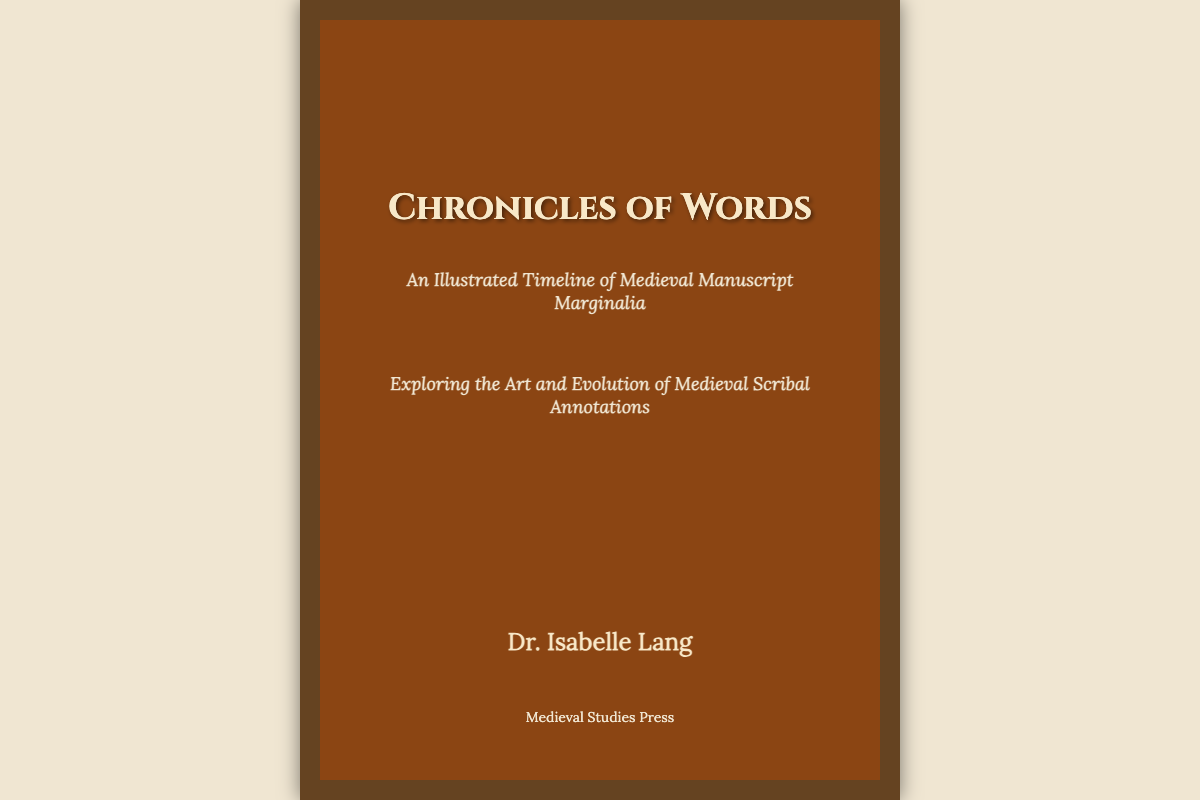What is the title of the book? The title of the book is prominently displayed at the top of the cover.
Answer: Chronicles of Words Who is the author? The author's name is listed near the bottom of the cover.
Answer: Dr. Isabelle Lang What is the subtitle of the book? The subtitle gives more context about the book's content and is located below the title.
Answer: An Illustrated Timeline of Medieval Manuscript Marginalia What is the publisher's name? The publisher's name appears at the bottom of the cover.
Answer: Medieval Studies Press How many marginalia doodles are shown on the cover? The cover features two marginalia doodles, as indicated by the design elements on the cover.
Answer: Two What colors dominate the book cover's design? The color palette can be observed in the background and text elements of the cover.
Answer: Brown and cream What type of illustrations are referenced in the subtitle? The subtitle suggests the type of content that will be illustrated throughout the book.
Answer: Manuscript Marginalia What is the main focus of the book according to the subtitle? The subtitle hints at the central theme explored within the pages of the book.
Answer: The Art and Evolution of Medieval Scribal Annotations What decorative elements are included in the cover design? The cover design uses decorative elements that enhance its medieval theme.
Answer: Marginalia and medieval decoration 